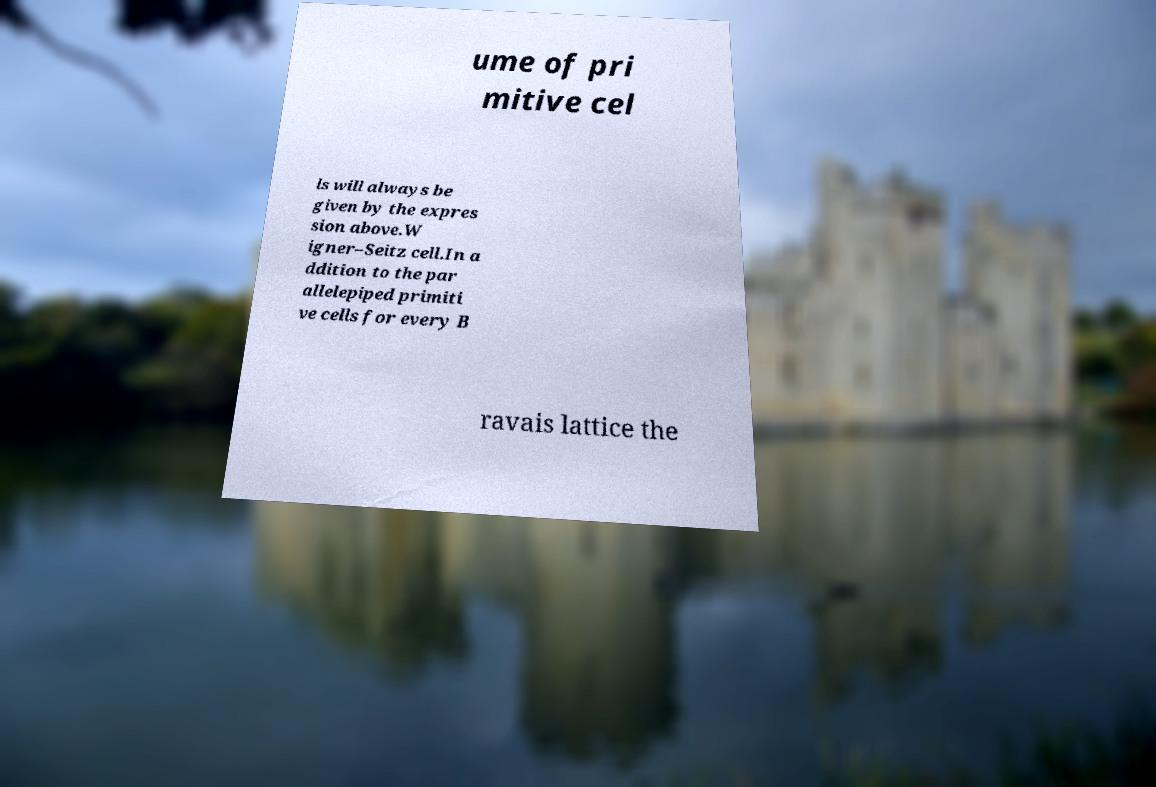There's text embedded in this image that I need extracted. Can you transcribe it verbatim? ume of pri mitive cel ls will always be given by the expres sion above.W igner–Seitz cell.In a ddition to the par allelepiped primiti ve cells for every B ravais lattice the 